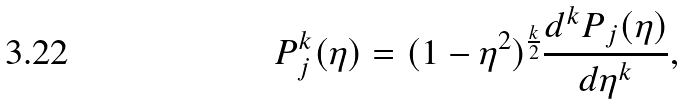Convert formula to latex. <formula><loc_0><loc_0><loc_500><loc_500>P _ { j } ^ { k } ( \eta ) = ( 1 - \eta ^ { 2 } ) ^ { \frac { k } { 2 } } \frac { d ^ { k } P _ { j } ( \eta ) } { d \eta ^ { k } } ,</formula> 